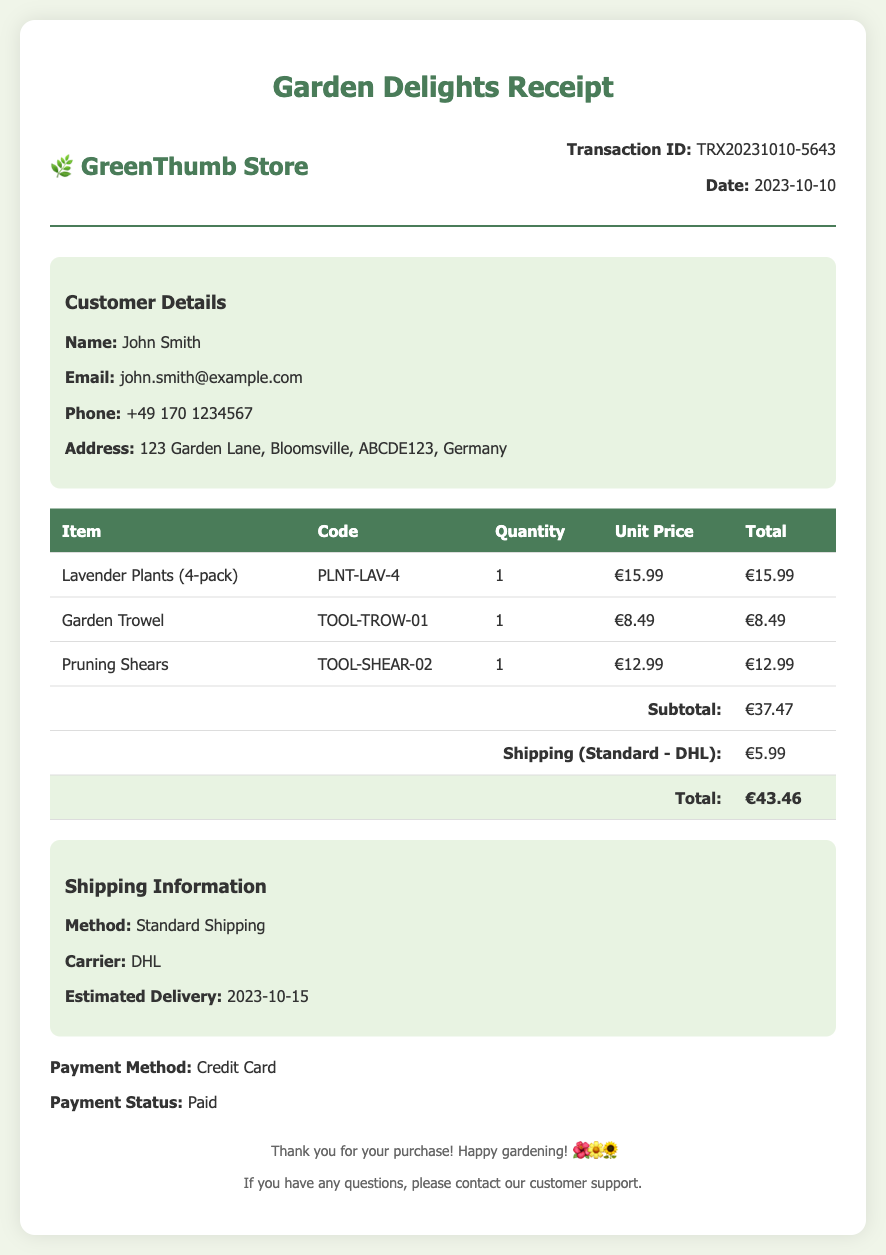What is the transaction ID? The transaction ID is listed under the transaction information section of the document.
Answer: TRX20231010-5643 What is the date of the transaction? The date of the transaction is also included in the transaction information section.
Answer: 2023-10-10 What is the total amount? The total amount is the final calculated sum in the receipt, including subtotal and shipping.
Answer: €43.46 How many Lavender Plants are included in the order? The quantity of Lavender Plants is provided in the itemized list of products in the document.
Answer: 1 What is the estimated delivery date? The estimated delivery date is mentioned in the shipping information section.
Answer: 2023-10-15 What shipping method was used? The shipping method is specified under the shipping information section of the document.
Answer: Standard Shipping Who is the carrier for the shipment? The carrier of the shipment is also listed in the shipping information section.
Answer: DHL What was the payment status? The payment status is mentioned near the bottom of the document.
Answer: Paid What is the contact email for customer support? The customer's email address is listed under customer details.
Answer: john.smith@example.com 